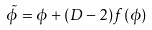<formula> <loc_0><loc_0><loc_500><loc_500>\tilde { \phi } = \phi + ( D - 2 ) f ( \phi )</formula> 